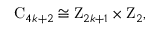Convert formula to latex. <formula><loc_0><loc_0><loc_500><loc_500>C _ { 4 k + 2 } \cong Z _ { 2 k + 1 } \times Z _ { 2 } ,</formula> 